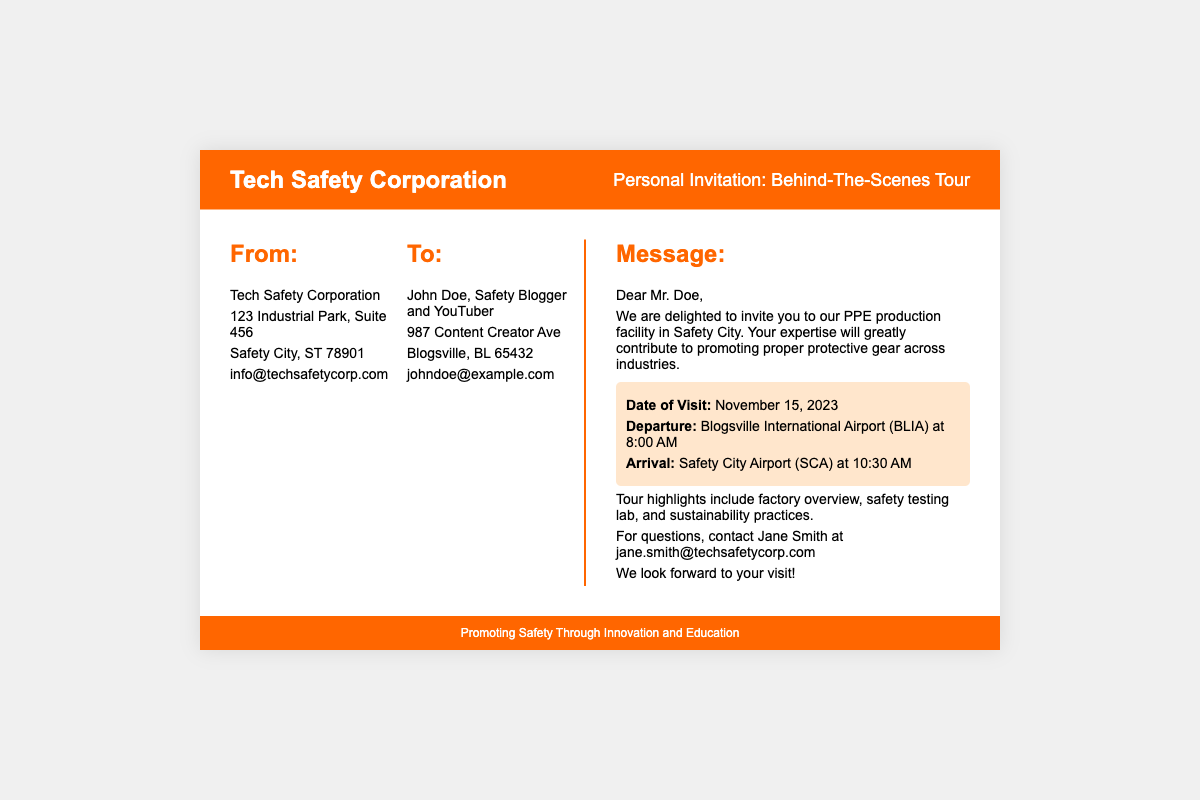what is the name of the sending organization? The sending organization is identified as Tech Safety Corporation in the document.
Answer: Tech Safety Corporation who is the recipient of the invitation? The recipient of the invitation is specifically addressed as John Doe in the document.
Answer: John Doe when is the date of the visit? The document clearly states the date of the visit, making it easy to retrieve this information.
Answer: November 15, 2023 what time does the departure occur? The document provides specific timings for the departure, which is part of the travel itinerary.
Answer: 8:00 AM which airport will the recipient arrive at? The document indicates the airport of arrival for the recipient as part of their itinerary.
Answer: Safety City Airport (SCA) what is one of the tour highlights mentioned? The document includes highlights of the tour and requests reasoning about them.
Answer: factory overview who should be contacted for questions? The document specifies a contact person for any inquiries, making it straightforward to identify who to reach out to.
Answer: Jane Smith what is the sender's email address? The document lists the sender's email as part of the contact details.
Answer: info@techsafetycorp.com what is the overall purpose of the document? The overall purpose of the document is to provide an invitation for a specific event, necessitating reasoning around the content structure.
Answer: Invitation to a tour 